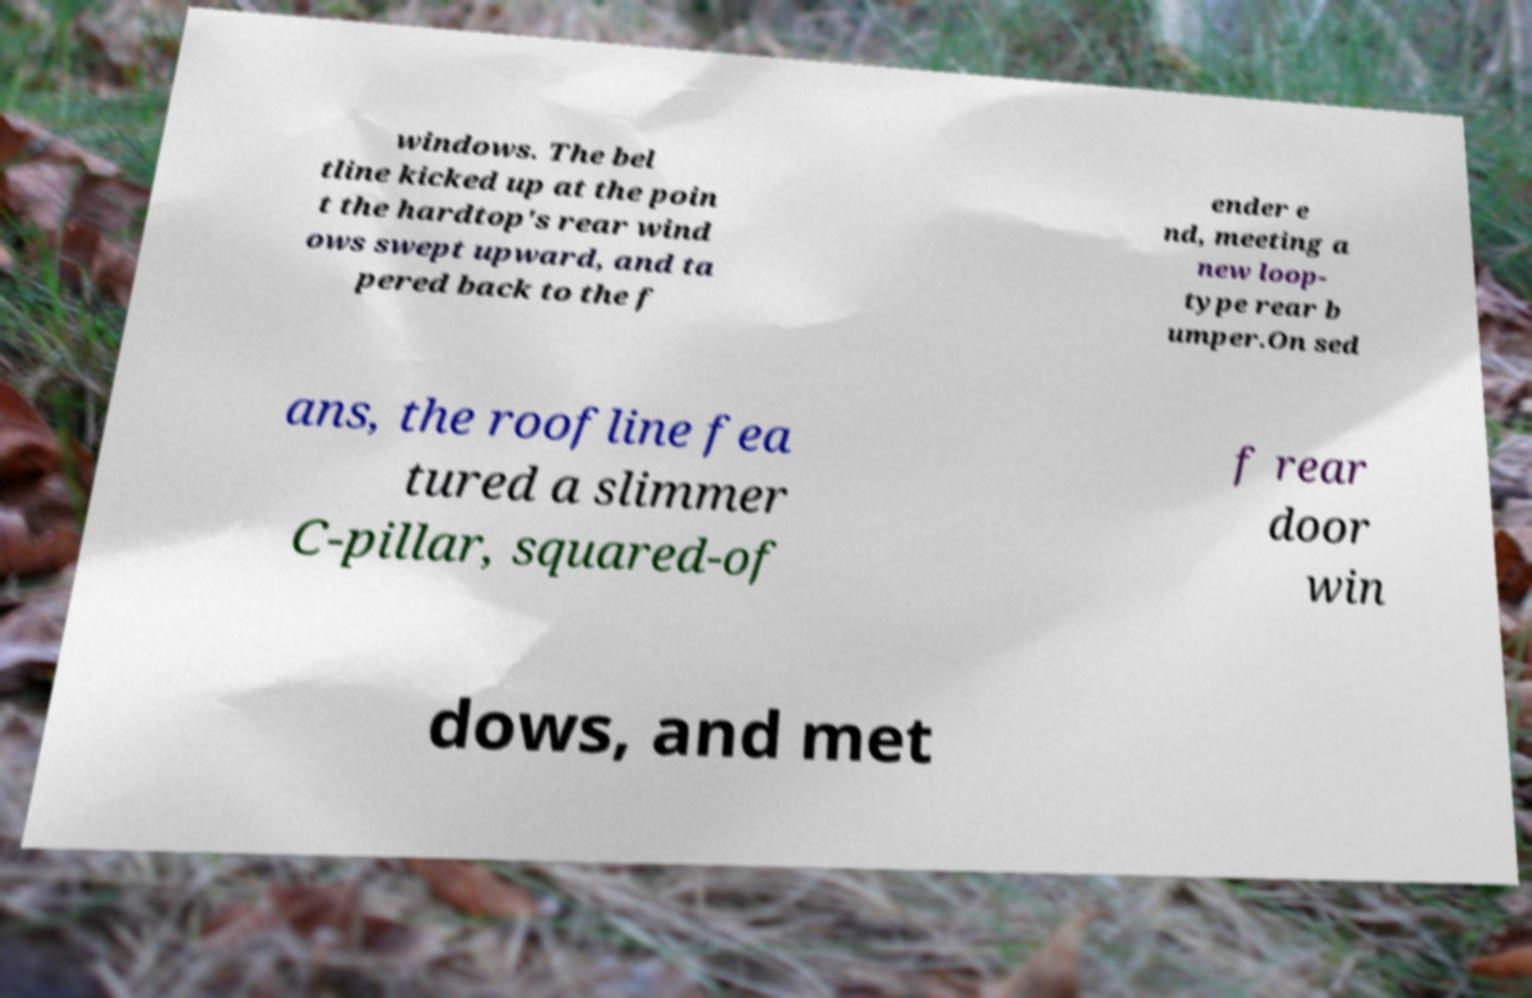Could you extract and type out the text from this image? windows. The bel tline kicked up at the poin t the hardtop's rear wind ows swept upward, and ta pered back to the f ender e nd, meeting a new loop- type rear b umper.On sed ans, the roofline fea tured a slimmer C-pillar, squared-of f rear door win dows, and met 